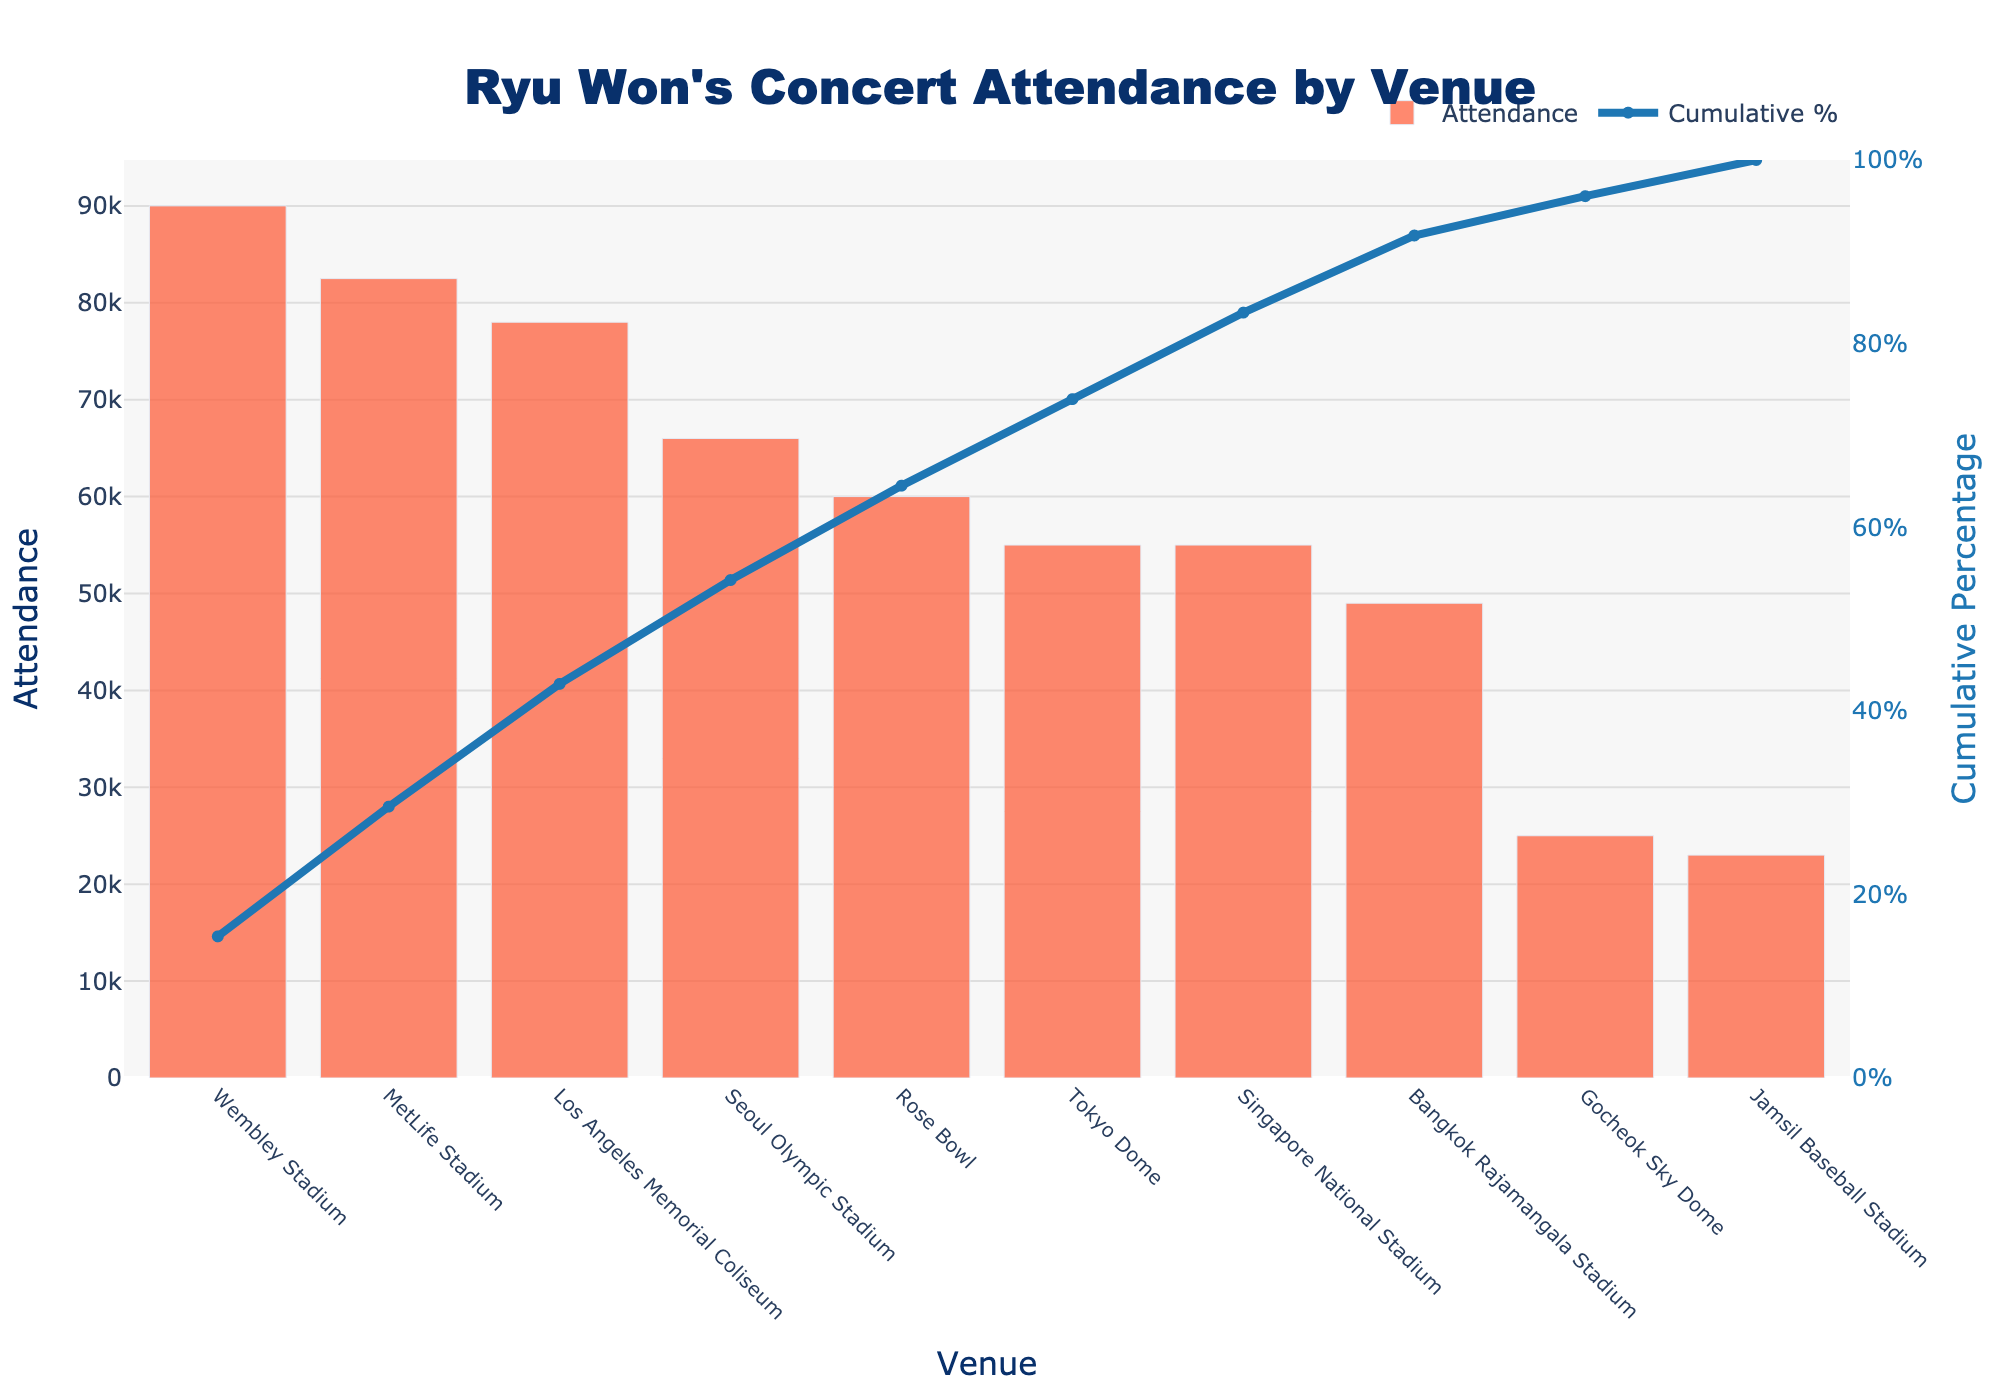What's the title of the figure? The title is typically displayed at the top center of the figure. Here, we can see "Ryu Won's Concert Attendance by Venue".
Answer: Ryu Won's Concert Attendance by Venue How many venues have been included in the figure? Count the number of distinct venue names on the x-axis of the bar chart. There are 10 unique venues listed.
Answer: 10 Which venue had the highest concert attendance? Look for the bar with the maximum height on the bar chart. Wembley Stadium is the highest with an attendance of 90,000.
Answer: Wembley Stadium What is the cumulative attendance percentage at MetLife Stadium? Check the cumulative percentage line corresponding to MetLife Stadium on the x-axis. The cumulative percentage is about 89%.
Answer: 89% What is the color of the bars representing attendance? The color of the bars can be seen by observing the bars in the figure. The bars are colored in a shade of orange.
Answer: Orange Which venue had a higher attendance, Rose Bowl or MetLife Stadium? Compare the heights of the bars for Rose Bowl and MetLife Stadium. MetLife Stadium had a higher attendance of 82,500 compared to Rose Bowl's 60,000.
Answer: MetLife Stadium What percentage of the cumulative attendance was reached after four venues? Find the cumulative line value after four venues (Seoul Olympic Stadium, MetLife Stadium, Los Angeles Memorial Coliseum, and Rose Bowl). The cumulative percentage is approximately 78%.
Answer: 78% What is the difference in attendance between the venue with the highest and the lowest attendance? Subtract the attendance of the smallest bar (Jamsil Baseball Stadium, 23,000) from the largest bar (Wembley Stadium, 90,000). The difference is 67,000.
Answer: 67,000 Is there a venue where the attendance reached the exact capacity? Check the bars and see if any venues have attendance equal to capacity. The Tokyo Dome and Gocheok Sky Dome both had attendance reaching their capacities of 55,000 and 25,000 respectively.
Answer: Tokyo Dome and Gocheok Sky Dome How many venues had an attendance greater than 50,000? Count the number of bars with attendance values over 50,000. There are five such venues: Wembley Stadium, MetLife Stadium, Los Angeles Memorial Coliseum, Seoul Olympic Stadium, and Rose Bowl.
Answer: 5 